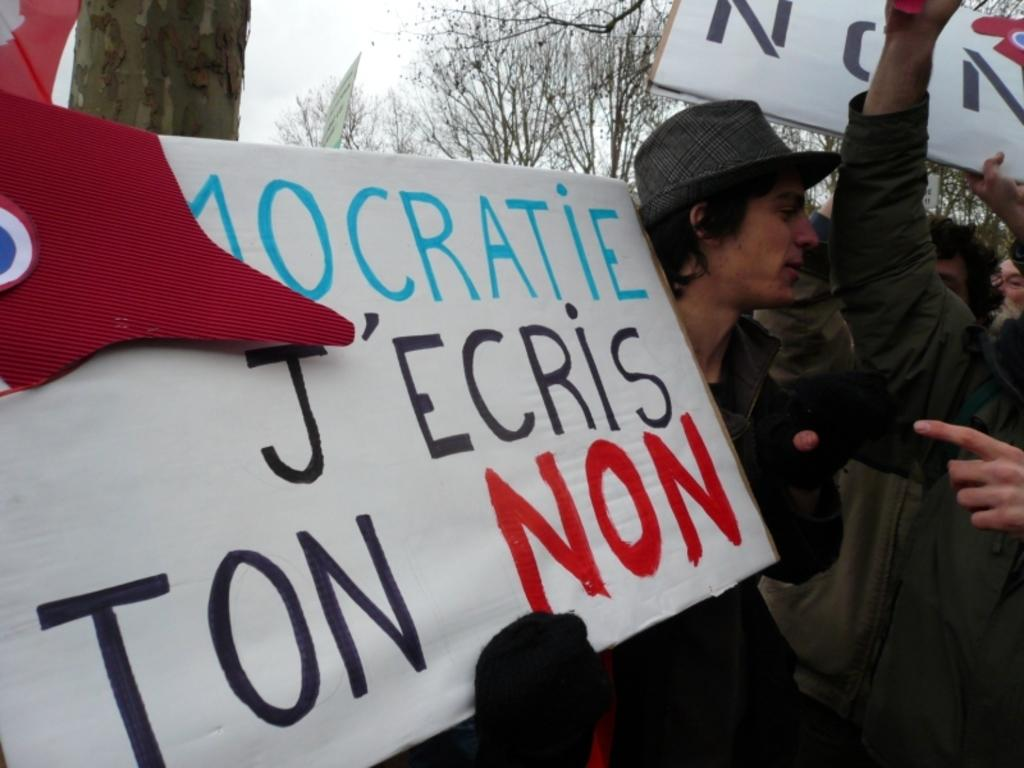Who or what can be seen in the image? There are people in the image. What are the people doing in the image? The people are standing and holding placards in their hands. What can be seen in the background of the image? There are trees and the sky visible in the background of the image. What type of lace can be seen on the people's legs in the image? There is no lace visible on the people's legs in the image. What is the value of the placards being held by the people in the image? The value of the placards cannot be determined from the image alone, as it depends on the content and context of the placards. 